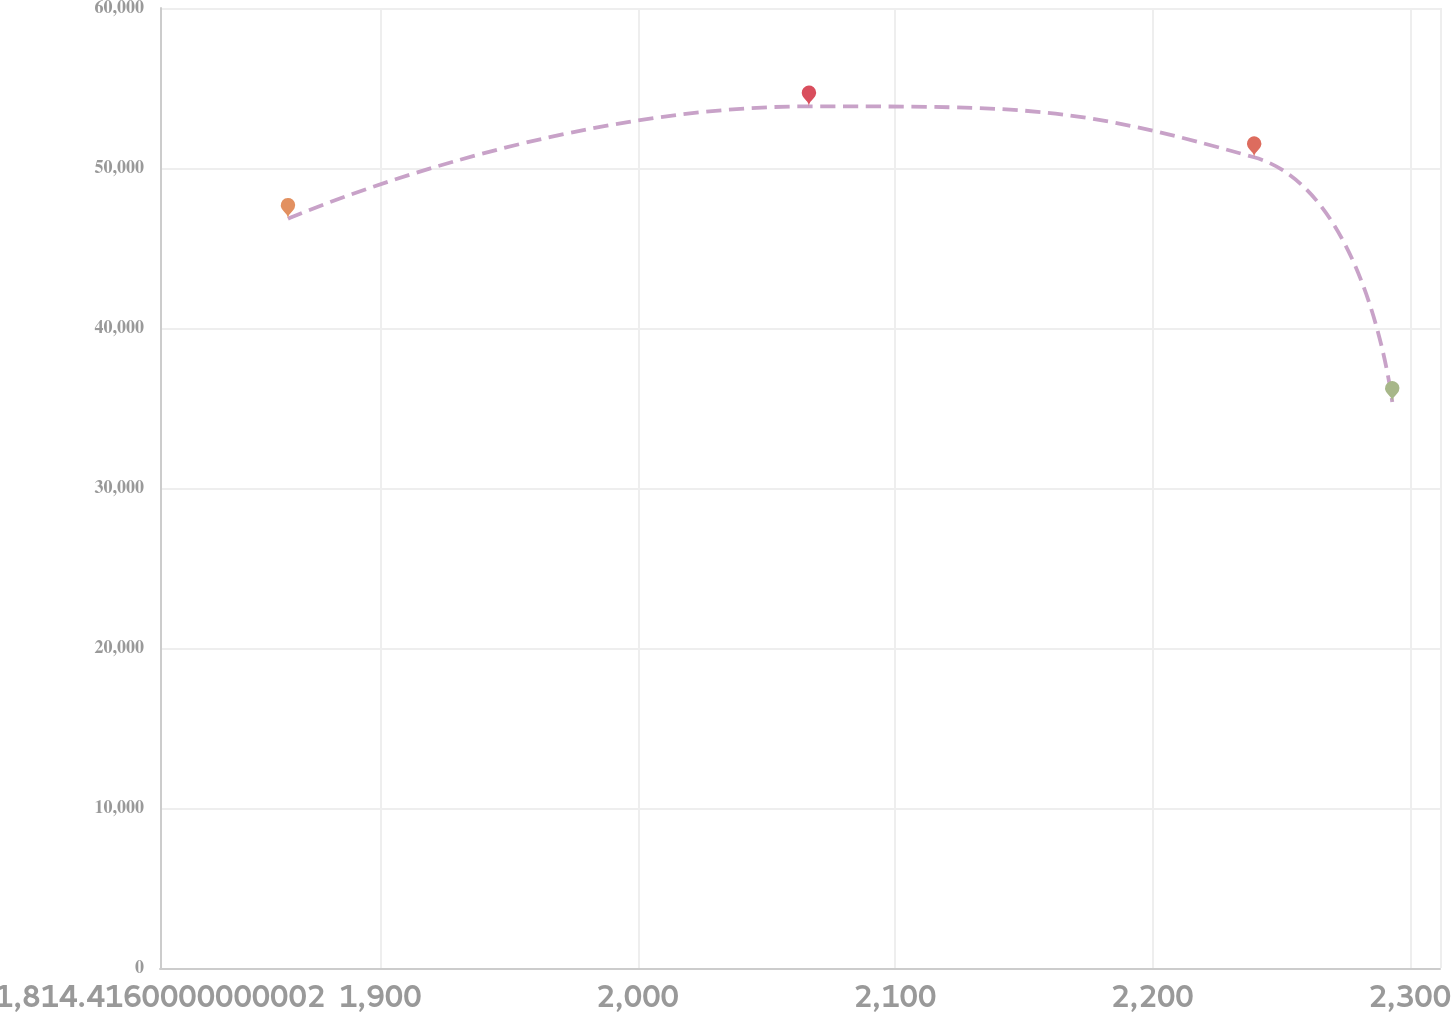Convert chart. <chart><loc_0><loc_0><loc_500><loc_500><line_chart><ecel><fcel>Unnamed: 1<nl><fcel>1864.15<fcel>46824.3<nl><fcel>2066.55<fcel>53851.9<nl><fcel>2239.55<fcel>50669.6<nl><fcel>2293.21<fcel>35379.8<nl><fcel>2361.49<fcel>28137.9<nl></chart> 